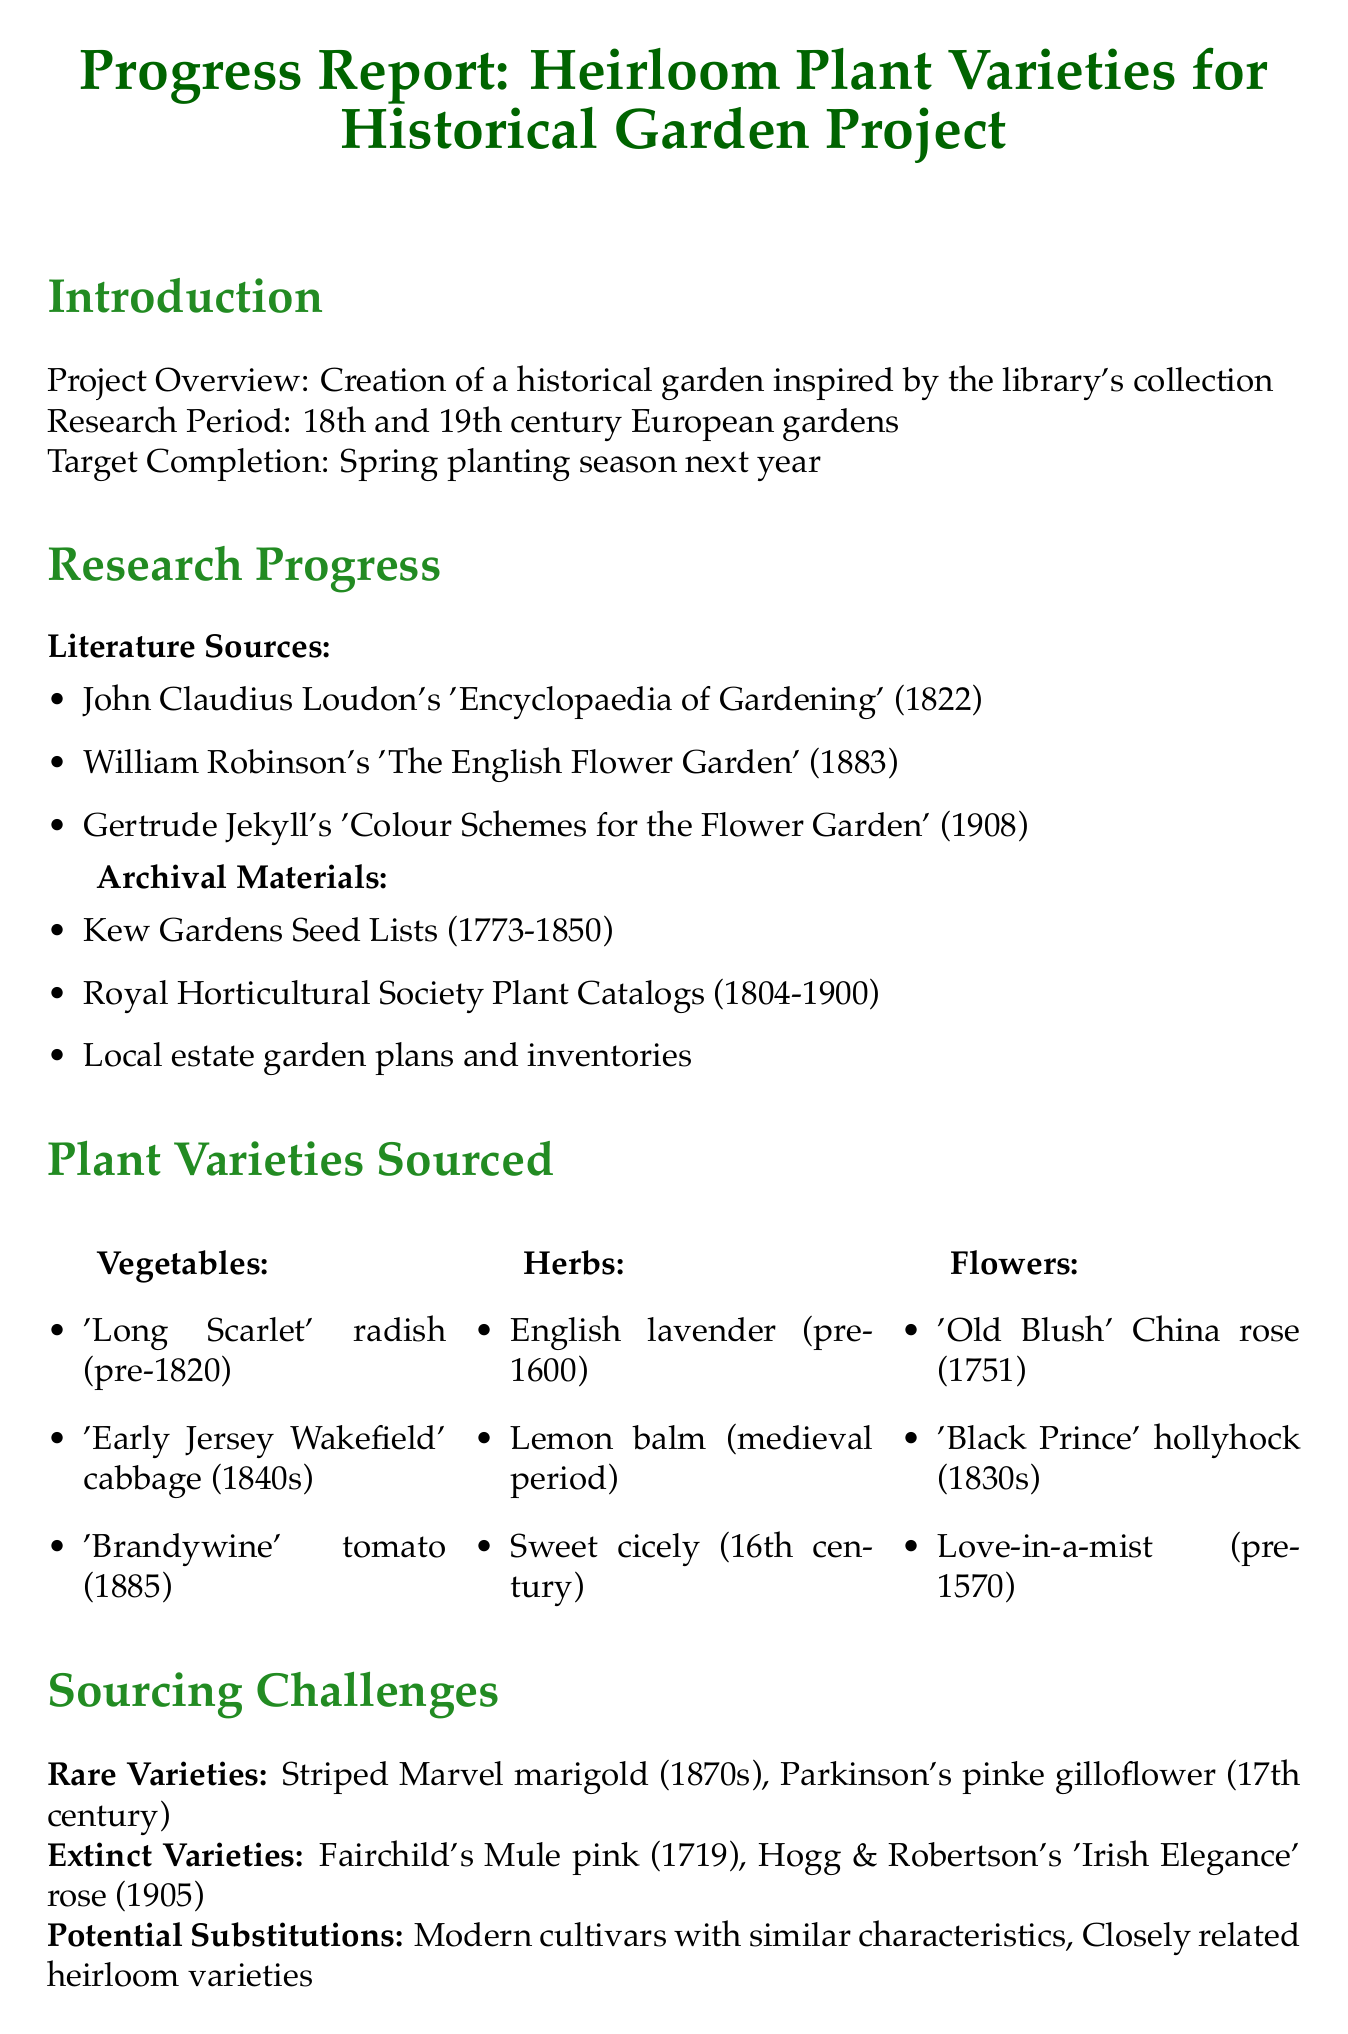What is the project overview? The project overview describes the creation of a historical garden inspired by the library's collection.
Answer: Creation of a historical garden inspired by the library's collection What are the three literature sources listed? The document lists three literature sources: John Claudius Loudon's 'Encyclopaedia of Gardening', William Robinson's 'The English Flower Garden', and Gertrude Jekyll's 'Colour Schemes for the Flower Garden'.
Answer: John Claudius Loudon's 'Encyclopaedia of Gardening', William Robinson's 'The English Flower Garden', Gertrude Jekyll's 'Colour Schemes for the Flower Garden' Which vegetable variety was sourced from the 1885? The vegetable variety sourced from the year 1885 is 'Brandywine' tomato.
Answer: 'Brandywine' tomato What is the total allocated funds for the project? The total allocated funds for the project as mentioned in the document is $15,000.
Answer: $15,000 What are the next steps outlined in the report? The next steps include finalizing the plant list, developing a propagation schedule, creating interpretive materials, and designing an appropriate layout and hardscaping.
Answer: Finalize plant list for each garden section, Develop propagation schedule for rare varieties, Create interpretive materials for visitors, Design period-appropriate layout and hardscaping What key challenges are identified in the conclusion? The key challenges identified in the conclusion are sourcing extinct varieties and adapting to the local climate.
Answer: Sourcing extinct varieties and adapting to local climate 